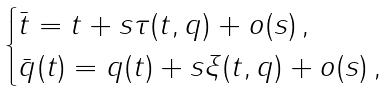Convert formula to latex. <formula><loc_0><loc_0><loc_500><loc_500>\begin{cases} \bar { t } = t + s \tau ( t , q ) + o ( s ) \, , \\ \bar { q } ( t ) = q ( t ) + s \xi ( t , q ) + o ( s ) \, , \\ \end{cases}</formula> 